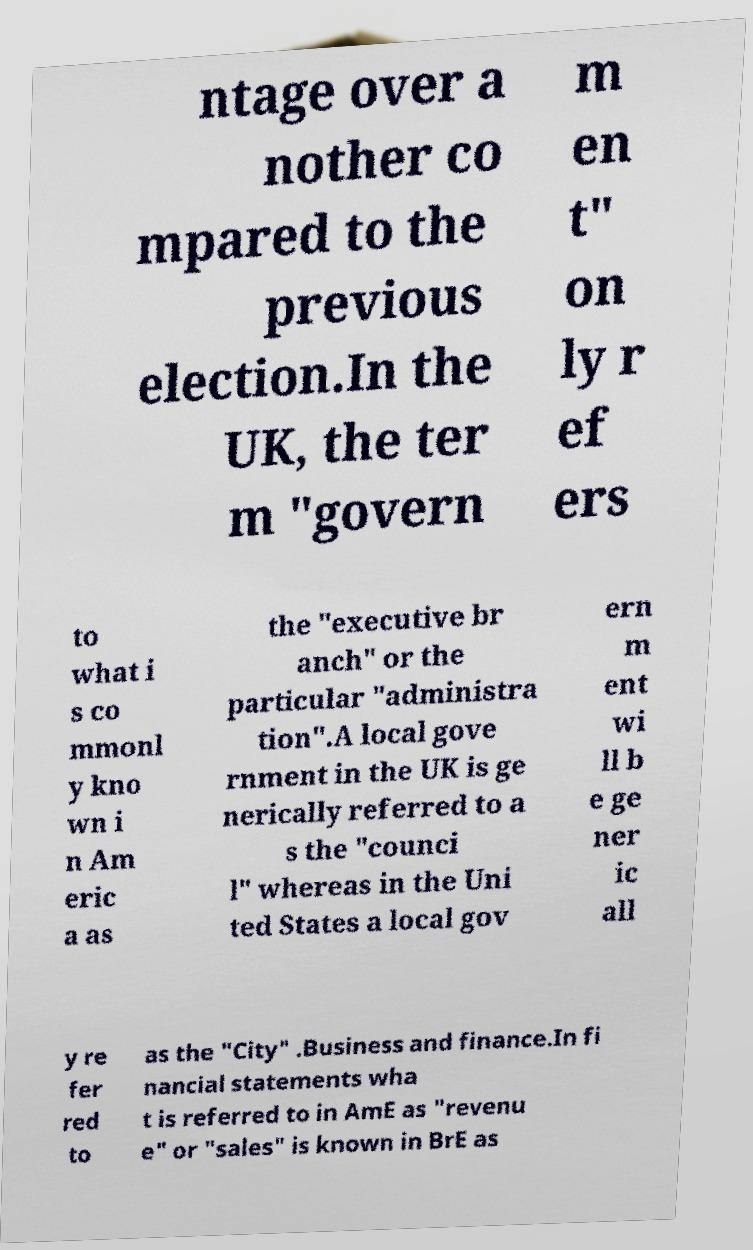Could you assist in decoding the text presented in this image and type it out clearly? ntage over a nother co mpared to the previous election.In the UK, the ter m "govern m en t" on ly r ef ers to what i s co mmonl y kno wn i n Am eric a as the "executive br anch" or the particular "administra tion".A local gove rnment in the UK is ge nerically referred to a s the "counci l" whereas in the Uni ted States a local gov ern m ent wi ll b e ge ner ic all y re fer red to as the "City" .Business and finance.In fi nancial statements wha t is referred to in AmE as "revenu e" or "sales" is known in BrE as 